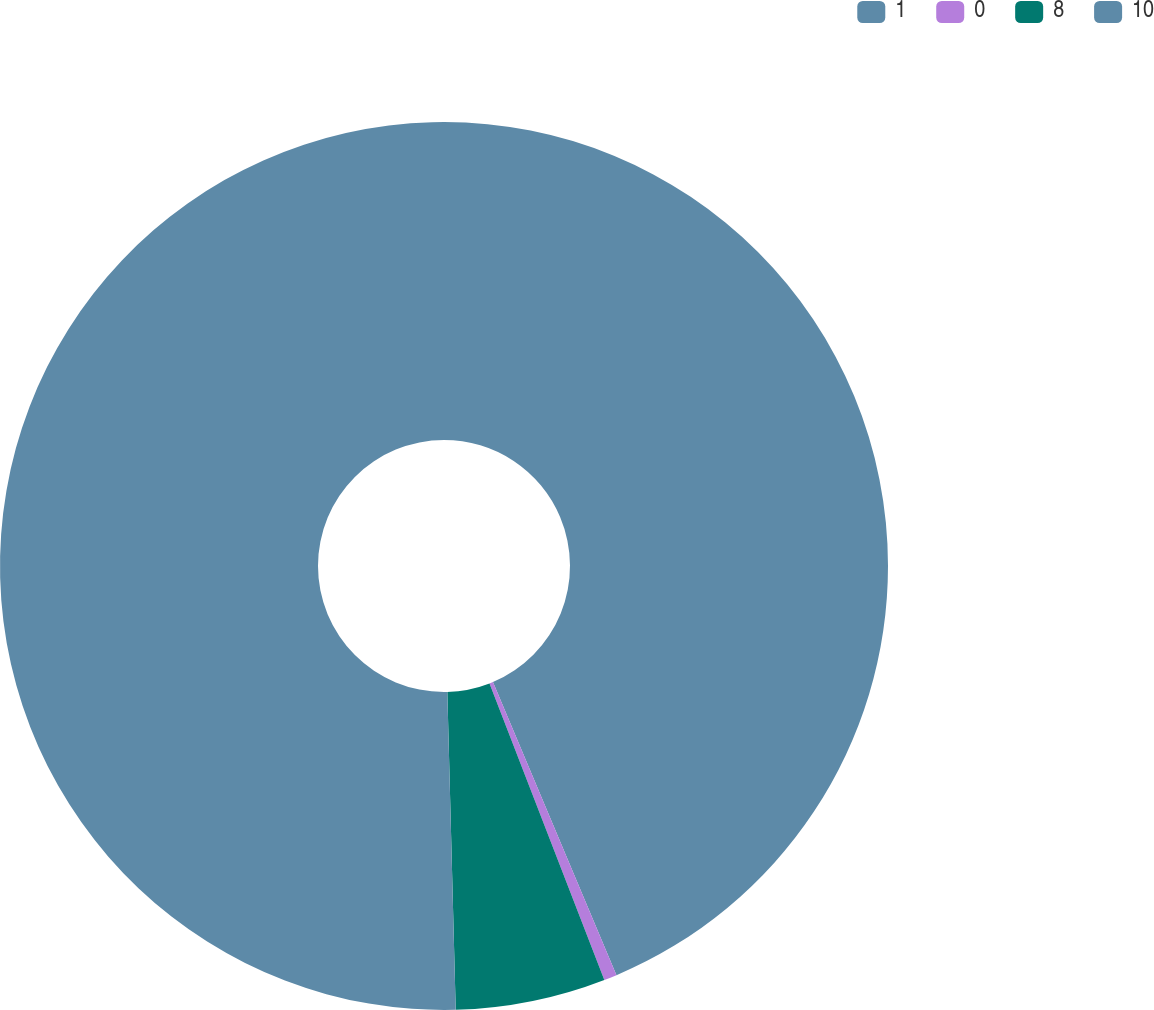<chart> <loc_0><loc_0><loc_500><loc_500><pie_chart><fcel>1<fcel>0<fcel>8<fcel>10<nl><fcel>43.65%<fcel>0.47%<fcel>5.46%<fcel>50.42%<nl></chart> 